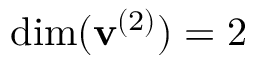<formula> <loc_0><loc_0><loc_500><loc_500>d i m ( v ^ { ( 2 ) } ) = 2</formula> 